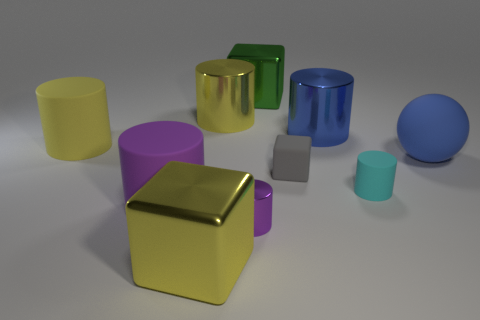There is a yellow metal object that is in front of the blue rubber ball; does it have the same size as the tiny gray block?
Ensure brevity in your answer.  No. There is a tiny purple metal thing; what shape is it?
Offer a terse response. Cylinder. What color is the big metal object right of the green metallic object that is left of the rubber sphere?
Offer a very short reply. Blue. Is the blue ball made of the same material as the thing behind the big yellow shiny cylinder?
Your response must be concise. No. There is a block in front of the matte block; what is it made of?
Ensure brevity in your answer.  Metal. Is the number of yellow metal objects that are behind the ball the same as the number of large yellow cylinders?
Provide a succinct answer. No. Are there any other things that are the same size as the purple shiny cylinder?
Give a very brief answer. Yes. What is the material of the big cube that is in front of the large blue object right of the blue cylinder?
Your answer should be very brief. Metal. There is a big matte thing that is both to the left of the tiny metal cylinder and in front of the yellow matte cylinder; what is its shape?
Offer a terse response. Cylinder. There is a cyan rubber object that is the same shape as the large yellow matte object; what size is it?
Keep it short and to the point. Small. 